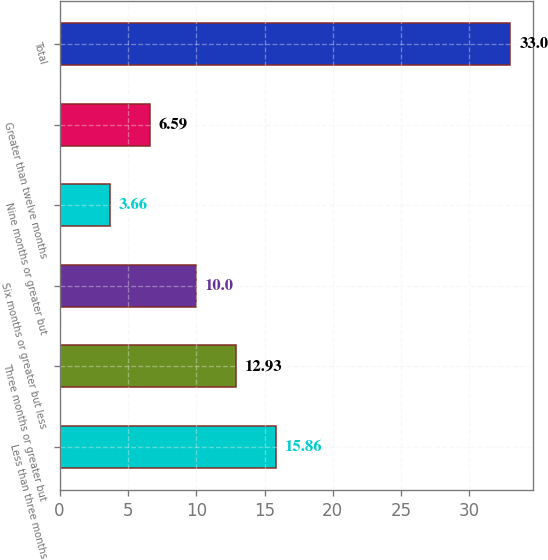<chart> <loc_0><loc_0><loc_500><loc_500><bar_chart><fcel>Less than three months<fcel>Three months or greater but<fcel>Six months or greater but less<fcel>Nine months or greater but<fcel>Greater than twelve months<fcel>Total<nl><fcel>15.86<fcel>12.93<fcel>10<fcel>3.66<fcel>6.59<fcel>33<nl></chart> 